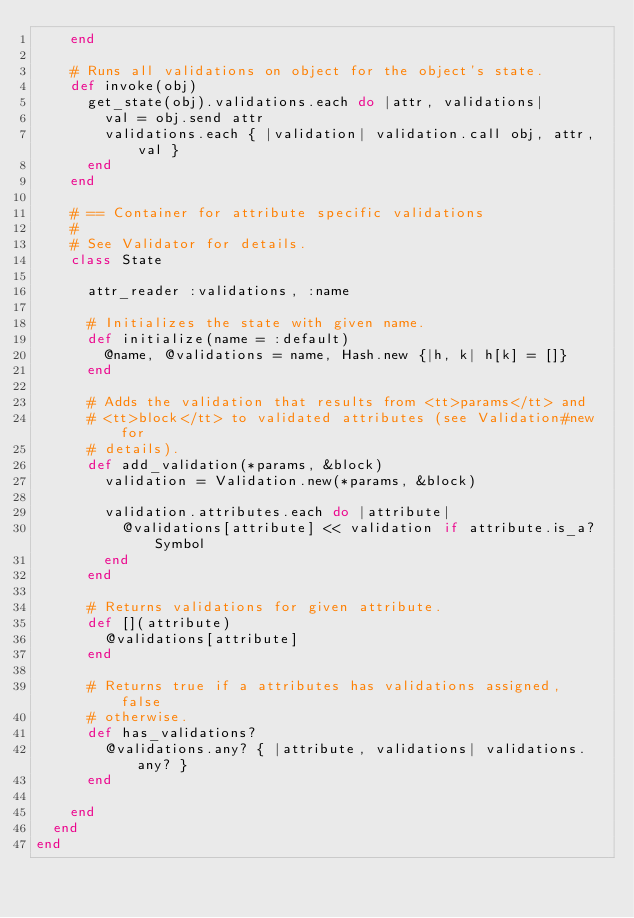Convert code to text. <code><loc_0><loc_0><loc_500><loc_500><_Ruby_>    end

    # Runs all validations on object for the object's state.
    def invoke(obj)
      get_state(obj).validations.each do |attr, validations|
        val = obj.send attr
        validations.each { |validation| validation.call obj, attr, val }
      end
    end

    # == Container for attribute specific validations
    #
    # See Validator for details.
    class State

      attr_reader :validations, :name

      # Initializes the state with given name.
      def initialize(name = :default)
        @name, @validations = name, Hash.new {|h, k| h[k] = []}
      end

      # Adds the validation that results from <tt>params</tt> and
      # <tt>block</tt> to validated attributes (see Validation#new for
      # details).
      def add_validation(*params, &block)
        validation = Validation.new(*params, &block)

        validation.attributes.each do |attribute|
          @validations[attribute] << validation if attribute.is_a? Symbol
        end
      end

      # Returns validations for given attribute.
      def [](attribute)
        @validations[attribute]
      end

      # Returns true if a attributes has validations assigned, false
      # otherwise.
      def has_validations?
        @validations.any? { |attribute, validations| validations.any? }
      end

    end
  end
end
</code> 